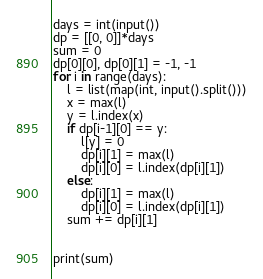<code> <loc_0><loc_0><loc_500><loc_500><_Python_>days = int(input())
dp = [[0, 0]]*days
sum = 0
dp[0][0], dp[0][1] = -1, -1
for i in range(days):
    l = list(map(int, input().split()))
    x = max(l)
    y = l.index(x)
    if dp[i-1][0] == y:
        l[y] = 0
        dp[i][1] = max(l)
        dp[i][0] = l.index(dp[i][1])
    else:
        dp[i][1] = max(l)
        dp[i][0] = l.index(dp[i][1])
    sum += dp[i][1]


print(sum)
</code> 